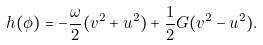<formula> <loc_0><loc_0><loc_500><loc_500>h ( \phi ) = - \frac { \omega } { 2 } ( v ^ { 2 } + u ^ { 2 } ) + \frac { 1 } { 2 } G ( v ^ { 2 } - u ^ { 2 } ) .</formula> 